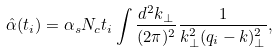<formula> <loc_0><loc_0><loc_500><loc_500>\hat { \alpha } ( t _ { i } ) = \alpha _ { s } N _ { c } t _ { i } \int \frac { d ^ { 2 } k _ { \perp } } { ( 2 \pi ) ^ { 2 } } \frac { 1 } { k _ { \perp } ^ { 2 } ( q _ { i } - k ) _ { \perp } ^ { 2 } } ,</formula> 